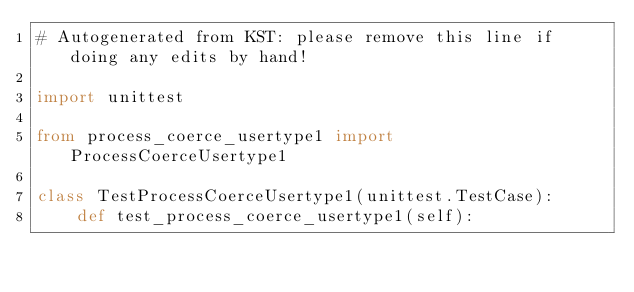Convert code to text. <code><loc_0><loc_0><loc_500><loc_500><_Python_># Autogenerated from KST: please remove this line if doing any edits by hand!

import unittest

from process_coerce_usertype1 import ProcessCoerceUsertype1

class TestProcessCoerceUsertype1(unittest.TestCase):
    def test_process_coerce_usertype1(self):</code> 